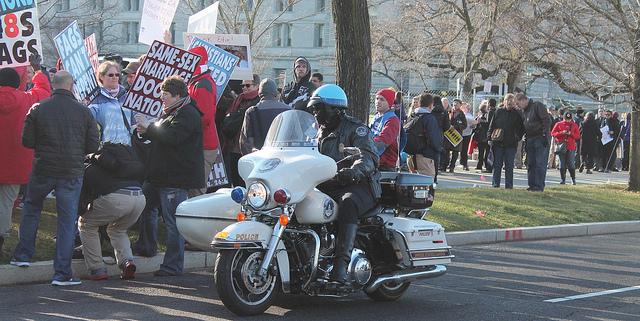What are they protesting?
Answer briefly. Same sex marriage. Are the people illegally in the street?
Concise answer only. No. Is there any police on the street?
Give a very brief answer. Yes. How many lights are on the front of the motorcycle?
Short answer required. 3. How many men are on the bike?
Write a very short answer. 1. 